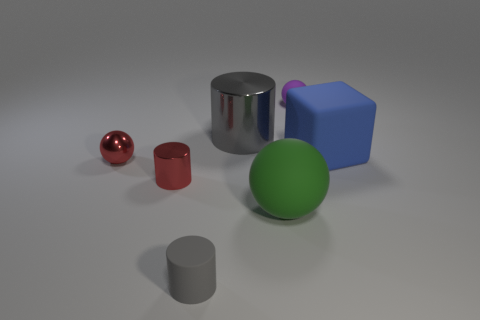Add 2 large purple rubber blocks. How many objects exist? 9 Subtract all cylinders. How many objects are left? 4 Add 3 large green matte things. How many large green matte things are left? 4 Add 3 purple shiny blocks. How many purple shiny blocks exist? 3 Subtract 0 green cubes. How many objects are left? 7 Subtract all small brown blocks. Subtract all tiny cylinders. How many objects are left? 5 